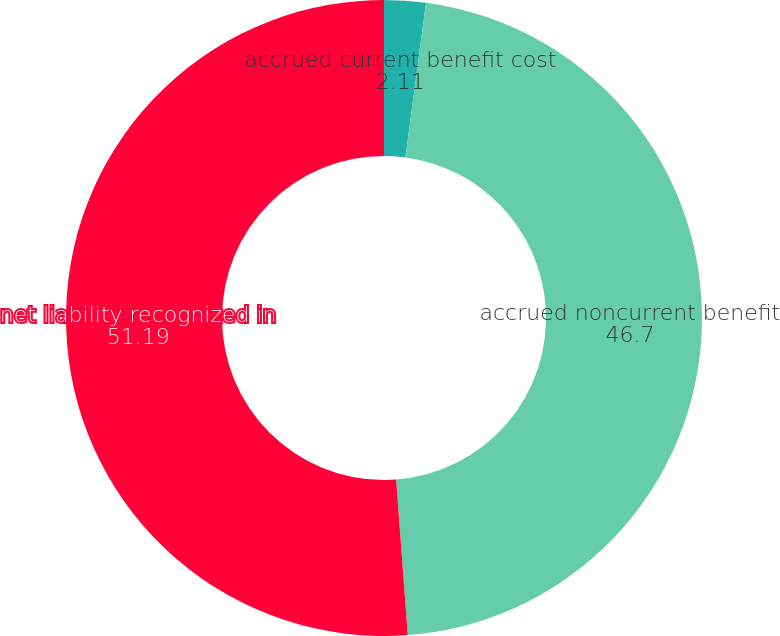Convert chart. <chart><loc_0><loc_0><loc_500><loc_500><pie_chart><fcel>accrued current benefit cost<fcel>accrued noncurrent benefit<fcel>net liability recognized in<nl><fcel>2.11%<fcel>46.7%<fcel>51.19%<nl></chart> 